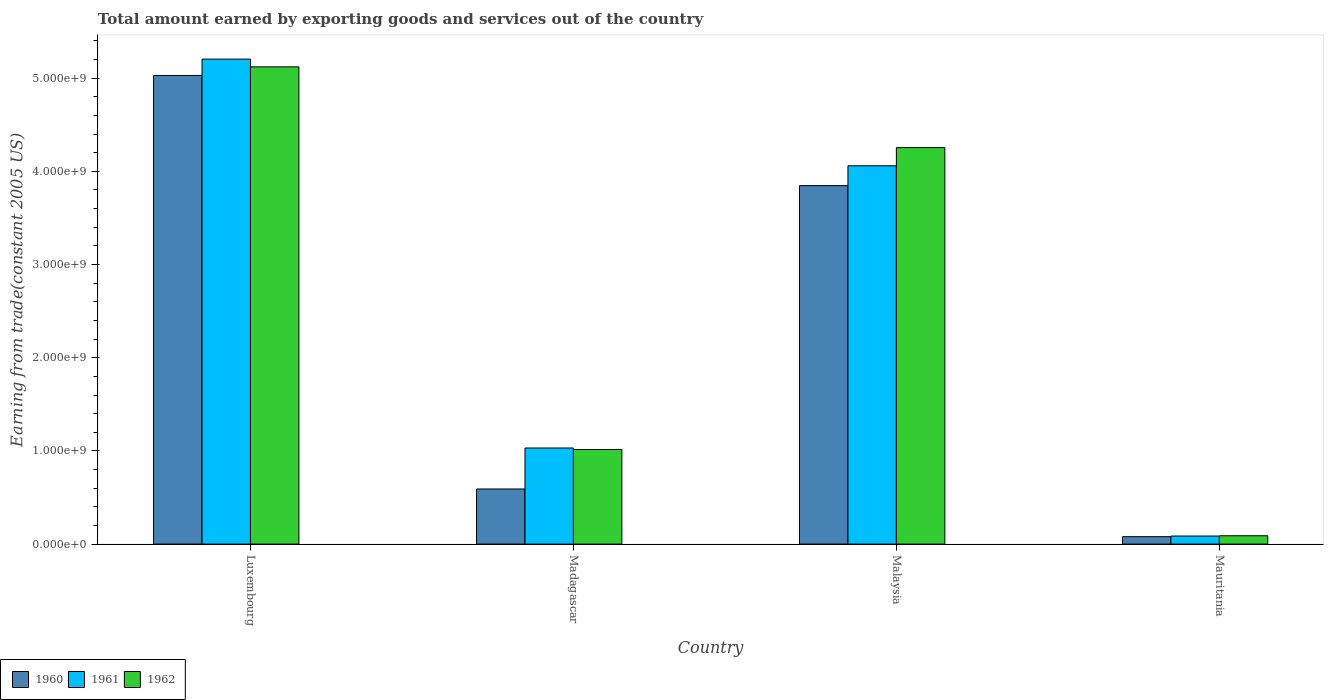How many different coloured bars are there?
Your answer should be compact. 3. How many groups of bars are there?
Give a very brief answer. 4. Are the number of bars per tick equal to the number of legend labels?
Give a very brief answer. Yes. Are the number of bars on each tick of the X-axis equal?
Offer a very short reply. Yes. How many bars are there on the 1st tick from the left?
Your response must be concise. 3. What is the label of the 3rd group of bars from the left?
Make the answer very short. Malaysia. What is the total amount earned by exporting goods and services in 1960 in Luxembourg?
Your answer should be compact. 5.03e+09. Across all countries, what is the maximum total amount earned by exporting goods and services in 1961?
Offer a terse response. 5.20e+09. Across all countries, what is the minimum total amount earned by exporting goods and services in 1960?
Offer a terse response. 7.97e+07. In which country was the total amount earned by exporting goods and services in 1961 maximum?
Ensure brevity in your answer.  Luxembourg. In which country was the total amount earned by exporting goods and services in 1962 minimum?
Your answer should be compact. Mauritania. What is the total total amount earned by exporting goods and services in 1960 in the graph?
Ensure brevity in your answer.  9.55e+09. What is the difference between the total amount earned by exporting goods and services in 1962 in Luxembourg and that in Mauritania?
Offer a terse response. 5.03e+09. What is the difference between the total amount earned by exporting goods and services in 1960 in Malaysia and the total amount earned by exporting goods and services in 1962 in Mauritania?
Offer a terse response. 3.76e+09. What is the average total amount earned by exporting goods and services in 1960 per country?
Your answer should be very brief. 2.39e+09. What is the difference between the total amount earned by exporting goods and services of/in 1961 and total amount earned by exporting goods and services of/in 1962 in Mauritania?
Provide a short and direct response. -3.07e+06. What is the ratio of the total amount earned by exporting goods and services in 1961 in Luxembourg to that in Malaysia?
Offer a very short reply. 1.28. Is the total amount earned by exporting goods and services in 1961 in Luxembourg less than that in Malaysia?
Your answer should be very brief. No. Is the difference between the total amount earned by exporting goods and services in 1961 in Madagascar and Malaysia greater than the difference between the total amount earned by exporting goods and services in 1962 in Madagascar and Malaysia?
Your response must be concise. Yes. What is the difference between the highest and the second highest total amount earned by exporting goods and services in 1960?
Provide a short and direct response. -1.18e+09. What is the difference between the highest and the lowest total amount earned by exporting goods and services in 1960?
Ensure brevity in your answer.  4.95e+09. What does the 2nd bar from the left in Mauritania represents?
Your answer should be compact. 1961. What does the 1st bar from the right in Luxembourg represents?
Provide a succinct answer. 1962. Is it the case that in every country, the sum of the total amount earned by exporting goods and services in 1960 and total amount earned by exporting goods and services in 1961 is greater than the total amount earned by exporting goods and services in 1962?
Provide a short and direct response. Yes. How many bars are there?
Offer a terse response. 12. Are the values on the major ticks of Y-axis written in scientific E-notation?
Offer a terse response. Yes. Where does the legend appear in the graph?
Keep it short and to the point. Bottom left. How many legend labels are there?
Offer a terse response. 3. What is the title of the graph?
Your answer should be compact. Total amount earned by exporting goods and services out of the country. Does "2003" appear as one of the legend labels in the graph?
Your response must be concise. No. What is the label or title of the X-axis?
Your answer should be compact. Country. What is the label or title of the Y-axis?
Provide a short and direct response. Earning from trade(constant 2005 US). What is the Earning from trade(constant 2005 US) of 1960 in Luxembourg?
Keep it short and to the point. 5.03e+09. What is the Earning from trade(constant 2005 US) of 1961 in Luxembourg?
Provide a succinct answer. 5.20e+09. What is the Earning from trade(constant 2005 US) in 1962 in Luxembourg?
Your response must be concise. 5.12e+09. What is the Earning from trade(constant 2005 US) in 1960 in Madagascar?
Your response must be concise. 5.92e+08. What is the Earning from trade(constant 2005 US) of 1961 in Madagascar?
Your answer should be compact. 1.03e+09. What is the Earning from trade(constant 2005 US) of 1962 in Madagascar?
Offer a very short reply. 1.02e+09. What is the Earning from trade(constant 2005 US) of 1960 in Malaysia?
Your response must be concise. 3.85e+09. What is the Earning from trade(constant 2005 US) in 1961 in Malaysia?
Make the answer very short. 4.06e+09. What is the Earning from trade(constant 2005 US) in 1962 in Malaysia?
Offer a terse response. 4.25e+09. What is the Earning from trade(constant 2005 US) of 1960 in Mauritania?
Provide a succinct answer. 7.97e+07. What is the Earning from trade(constant 2005 US) of 1961 in Mauritania?
Your response must be concise. 8.64e+07. What is the Earning from trade(constant 2005 US) in 1962 in Mauritania?
Keep it short and to the point. 8.95e+07. Across all countries, what is the maximum Earning from trade(constant 2005 US) in 1960?
Your answer should be compact. 5.03e+09. Across all countries, what is the maximum Earning from trade(constant 2005 US) in 1961?
Your answer should be compact. 5.20e+09. Across all countries, what is the maximum Earning from trade(constant 2005 US) of 1962?
Your response must be concise. 5.12e+09. Across all countries, what is the minimum Earning from trade(constant 2005 US) of 1960?
Your answer should be very brief. 7.97e+07. Across all countries, what is the minimum Earning from trade(constant 2005 US) of 1961?
Your response must be concise. 8.64e+07. Across all countries, what is the minimum Earning from trade(constant 2005 US) of 1962?
Provide a succinct answer. 8.95e+07. What is the total Earning from trade(constant 2005 US) of 1960 in the graph?
Offer a terse response. 9.55e+09. What is the total Earning from trade(constant 2005 US) in 1961 in the graph?
Offer a very short reply. 1.04e+1. What is the total Earning from trade(constant 2005 US) in 1962 in the graph?
Keep it short and to the point. 1.05e+1. What is the difference between the Earning from trade(constant 2005 US) of 1960 in Luxembourg and that in Madagascar?
Give a very brief answer. 4.44e+09. What is the difference between the Earning from trade(constant 2005 US) in 1961 in Luxembourg and that in Madagascar?
Provide a short and direct response. 4.17e+09. What is the difference between the Earning from trade(constant 2005 US) of 1962 in Luxembourg and that in Madagascar?
Offer a very short reply. 4.11e+09. What is the difference between the Earning from trade(constant 2005 US) of 1960 in Luxembourg and that in Malaysia?
Provide a short and direct response. 1.18e+09. What is the difference between the Earning from trade(constant 2005 US) of 1961 in Luxembourg and that in Malaysia?
Your response must be concise. 1.14e+09. What is the difference between the Earning from trade(constant 2005 US) of 1962 in Luxembourg and that in Malaysia?
Provide a short and direct response. 8.66e+08. What is the difference between the Earning from trade(constant 2005 US) in 1960 in Luxembourg and that in Mauritania?
Your response must be concise. 4.95e+09. What is the difference between the Earning from trade(constant 2005 US) of 1961 in Luxembourg and that in Mauritania?
Provide a succinct answer. 5.12e+09. What is the difference between the Earning from trade(constant 2005 US) in 1962 in Luxembourg and that in Mauritania?
Your answer should be very brief. 5.03e+09. What is the difference between the Earning from trade(constant 2005 US) of 1960 in Madagascar and that in Malaysia?
Ensure brevity in your answer.  -3.26e+09. What is the difference between the Earning from trade(constant 2005 US) in 1961 in Madagascar and that in Malaysia?
Ensure brevity in your answer.  -3.03e+09. What is the difference between the Earning from trade(constant 2005 US) in 1962 in Madagascar and that in Malaysia?
Ensure brevity in your answer.  -3.24e+09. What is the difference between the Earning from trade(constant 2005 US) in 1960 in Madagascar and that in Mauritania?
Your answer should be very brief. 5.12e+08. What is the difference between the Earning from trade(constant 2005 US) of 1961 in Madagascar and that in Mauritania?
Ensure brevity in your answer.  9.45e+08. What is the difference between the Earning from trade(constant 2005 US) in 1962 in Madagascar and that in Mauritania?
Make the answer very short. 9.26e+08. What is the difference between the Earning from trade(constant 2005 US) of 1960 in Malaysia and that in Mauritania?
Ensure brevity in your answer.  3.77e+09. What is the difference between the Earning from trade(constant 2005 US) of 1961 in Malaysia and that in Mauritania?
Make the answer very short. 3.97e+09. What is the difference between the Earning from trade(constant 2005 US) in 1962 in Malaysia and that in Mauritania?
Provide a succinct answer. 4.17e+09. What is the difference between the Earning from trade(constant 2005 US) in 1960 in Luxembourg and the Earning from trade(constant 2005 US) in 1961 in Madagascar?
Your answer should be very brief. 4.00e+09. What is the difference between the Earning from trade(constant 2005 US) in 1960 in Luxembourg and the Earning from trade(constant 2005 US) in 1962 in Madagascar?
Provide a short and direct response. 4.01e+09. What is the difference between the Earning from trade(constant 2005 US) in 1961 in Luxembourg and the Earning from trade(constant 2005 US) in 1962 in Madagascar?
Offer a terse response. 4.19e+09. What is the difference between the Earning from trade(constant 2005 US) of 1960 in Luxembourg and the Earning from trade(constant 2005 US) of 1961 in Malaysia?
Provide a succinct answer. 9.69e+08. What is the difference between the Earning from trade(constant 2005 US) in 1960 in Luxembourg and the Earning from trade(constant 2005 US) in 1962 in Malaysia?
Make the answer very short. 7.74e+08. What is the difference between the Earning from trade(constant 2005 US) in 1961 in Luxembourg and the Earning from trade(constant 2005 US) in 1962 in Malaysia?
Your answer should be compact. 9.49e+08. What is the difference between the Earning from trade(constant 2005 US) of 1960 in Luxembourg and the Earning from trade(constant 2005 US) of 1961 in Mauritania?
Give a very brief answer. 4.94e+09. What is the difference between the Earning from trade(constant 2005 US) of 1960 in Luxembourg and the Earning from trade(constant 2005 US) of 1962 in Mauritania?
Keep it short and to the point. 4.94e+09. What is the difference between the Earning from trade(constant 2005 US) in 1961 in Luxembourg and the Earning from trade(constant 2005 US) in 1962 in Mauritania?
Provide a succinct answer. 5.11e+09. What is the difference between the Earning from trade(constant 2005 US) of 1960 in Madagascar and the Earning from trade(constant 2005 US) of 1961 in Malaysia?
Give a very brief answer. -3.47e+09. What is the difference between the Earning from trade(constant 2005 US) in 1960 in Madagascar and the Earning from trade(constant 2005 US) in 1962 in Malaysia?
Ensure brevity in your answer.  -3.66e+09. What is the difference between the Earning from trade(constant 2005 US) of 1961 in Madagascar and the Earning from trade(constant 2005 US) of 1962 in Malaysia?
Your answer should be very brief. -3.22e+09. What is the difference between the Earning from trade(constant 2005 US) of 1960 in Madagascar and the Earning from trade(constant 2005 US) of 1961 in Mauritania?
Offer a very short reply. 5.05e+08. What is the difference between the Earning from trade(constant 2005 US) of 1960 in Madagascar and the Earning from trade(constant 2005 US) of 1962 in Mauritania?
Provide a succinct answer. 5.02e+08. What is the difference between the Earning from trade(constant 2005 US) in 1961 in Madagascar and the Earning from trade(constant 2005 US) in 1962 in Mauritania?
Your response must be concise. 9.42e+08. What is the difference between the Earning from trade(constant 2005 US) in 1960 in Malaysia and the Earning from trade(constant 2005 US) in 1961 in Mauritania?
Ensure brevity in your answer.  3.76e+09. What is the difference between the Earning from trade(constant 2005 US) in 1960 in Malaysia and the Earning from trade(constant 2005 US) in 1962 in Mauritania?
Offer a very short reply. 3.76e+09. What is the difference between the Earning from trade(constant 2005 US) of 1961 in Malaysia and the Earning from trade(constant 2005 US) of 1962 in Mauritania?
Give a very brief answer. 3.97e+09. What is the average Earning from trade(constant 2005 US) of 1960 per country?
Ensure brevity in your answer.  2.39e+09. What is the average Earning from trade(constant 2005 US) of 1961 per country?
Your answer should be very brief. 2.60e+09. What is the average Earning from trade(constant 2005 US) in 1962 per country?
Ensure brevity in your answer.  2.62e+09. What is the difference between the Earning from trade(constant 2005 US) in 1960 and Earning from trade(constant 2005 US) in 1961 in Luxembourg?
Provide a succinct answer. -1.75e+08. What is the difference between the Earning from trade(constant 2005 US) of 1960 and Earning from trade(constant 2005 US) of 1962 in Luxembourg?
Give a very brief answer. -9.22e+07. What is the difference between the Earning from trade(constant 2005 US) in 1961 and Earning from trade(constant 2005 US) in 1962 in Luxembourg?
Give a very brief answer. 8.31e+07. What is the difference between the Earning from trade(constant 2005 US) of 1960 and Earning from trade(constant 2005 US) of 1961 in Madagascar?
Your answer should be compact. -4.40e+08. What is the difference between the Earning from trade(constant 2005 US) in 1960 and Earning from trade(constant 2005 US) in 1962 in Madagascar?
Ensure brevity in your answer.  -4.24e+08. What is the difference between the Earning from trade(constant 2005 US) in 1961 and Earning from trade(constant 2005 US) in 1962 in Madagascar?
Make the answer very short. 1.61e+07. What is the difference between the Earning from trade(constant 2005 US) of 1960 and Earning from trade(constant 2005 US) of 1961 in Malaysia?
Make the answer very short. -2.13e+08. What is the difference between the Earning from trade(constant 2005 US) in 1960 and Earning from trade(constant 2005 US) in 1962 in Malaysia?
Offer a terse response. -4.08e+08. What is the difference between the Earning from trade(constant 2005 US) of 1961 and Earning from trade(constant 2005 US) of 1962 in Malaysia?
Your answer should be compact. -1.95e+08. What is the difference between the Earning from trade(constant 2005 US) in 1960 and Earning from trade(constant 2005 US) in 1961 in Mauritania?
Make the answer very short. -6.74e+06. What is the difference between the Earning from trade(constant 2005 US) in 1960 and Earning from trade(constant 2005 US) in 1962 in Mauritania?
Keep it short and to the point. -9.81e+06. What is the difference between the Earning from trade(constant 2005 US) of 1961 and Earning from trade(constant 2005 US) of 1962 in Mauritania?
Your answer should be compact. -3.07e+06. What is the ratio of the Earning from trade(constant 2005 US) of 1960 in Luxembourg to that in Madagascar?
Make the answer very short. 8.5. What is the ratio of the Earning from trade(constant 2005 US) in 1961 in Luxembourg to that in Madagascar?
Keep it short and to the point. 5.05. What is the ratio of the Earning from trade(constant 2005 US) of 1962 in Luxembourg to that in Madagascar?
Your response must be concise. 5.04. What is the ratio of the Earning from trade(constant 2005 US) in 1960 in Luxembourg to that in Malaysia?
Give a very brief answer. 1.31. What is the ratio of the Earning from trade(constant 2005 US) of 1961 in Luxembourg to that in Malaysia?
Your response must be concise. 1.28. What is the ratio of the Earning from trade(constant 2005 US) in 1962 in Luxembourg to that in Malaysia?
Provide a succinct answer. 1.2. What is the ratio of the Earning from trade(constant 2005 US) of 1960 in Luxembourg to that in Mauritania?
Provide a succinct answer. 63.1. What is the ratio of the Earning from trade(constant 2005 US) in 1961 in Luxembourg to that in Mauritania?
Your response must be concise. 60.2. What is the ratio of the Earning from trade(constant 2005 US) of 1962 in Luxembourg to that in Mauritania?
Make the answer very short. 57.21. What is the ratio of the Earning from trade(constant 2005 US) in 1960 in Madagascar to that in Malaysia?
Offer a very short reply. 0.15. What is the ratio of the Earning from trade(constant 2005 US) in 1961 in Madagascar to that in Malaysia?
Your answer should be compact. 0.25. What is the ratio of the Earning from trade(constant 2005 US) of 1962 in Madagascar to that in Malaysia?
Make the answer very short. 0.24. What is the ratio of the Earning from trade(constant 2005 US) of 1960 in Madagascar to that in Mauritania?
Give a very brief answer. 7.42. What is the ratio of the Earning from trade(constant 2005 US) of 1961 in Madagascar to that in Mauritania?
Provide a short and direct response. 11.93. What is the ratio of the Earning from trade(constant 2005 US) of 1962 in Madagascar to that in Mauritania?
Ensure brevity in your answer.  11.34. What is the ratio of the Earning from trade(constant 2005 US) in 1960 in Malaysia to that in Mauritania?
Ensure brevity in your answer.  48.26. What is the ratio of the Earning from trade(constant 2005 US) in 1961 in Malaysia to that in Mauritania?
Provide a short and direct response. 46.96. What is the ratio of the Earning from trade(constant 2005 US) of 1962 in Malaysia to that in Mauritania?
Ensure brevity in your answer.  47.53. What is the difference between the highest and the second highest Earning from trade(constant 2005 US) in 1960?
Make the answer very short. 1.18e+09. What is the difference between the highest and the second highest Earning from trade(constant 2005 US) of 1961?
Provide a succinct answer. 1.14e+09. What is the difference between the highest and the second highest Earning from trade(constant 2005 US) of 1962?
Your answer should be compact. 8.66e+08. What is the difference between the highest and the lowest Earning from trade(constant 2005 US) in 1960?
Your answer should be compact. 4.95e+09. What is the difference between the highest and the lowest Earning from trade(constant 2005 US) of 1961?
Offer a very short reply. 5.12e+09. What is the difference between the highest and the lowest Earning from trade(constant 2005 US) of 1962?
Offer a very short reply. 5.03e+09. 